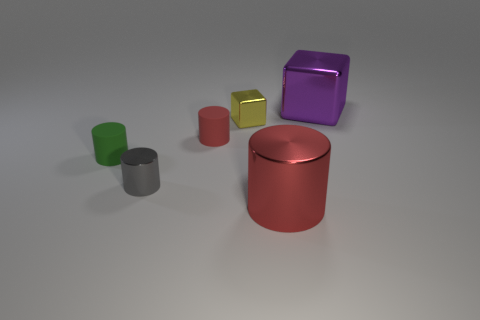Does the tiny metal cylinder have the same color as the large cylinder?
Your answer should be compact. No. What number of blocks have the same color as the big cylinder?
Provide a succinct answer. 0. What number of tiny things are either blocks or gray objects?
Offer a very short reply. 2. There is a cylinder that is made of the same material as the green thing; what is its color?
Your answer should be very brief. Red. There is a tiny matte thing right of the small shiny cylinder; does it have the same shape as the large shiny thing in front of the yellow cube?
Make the answer very short. Yes. How many shiny objects are either small gray things or yellow objects?
Make the answer very short. 2. What material is the object that is the same color as the big cylinder?
Your response must be concise. Rubber. There is a tiny cylinder that is on the left side of the gray cylinder; what is it made of?
Give a very brief answer. Rubber. Does the large object that is to the left of the purple thing have the same material as the gray thing?
Offer a terse response. Yes. How many things are large green rubber spheres or blocks that are left of the large purple thing?
Ensure brevity in your answer.  1. 